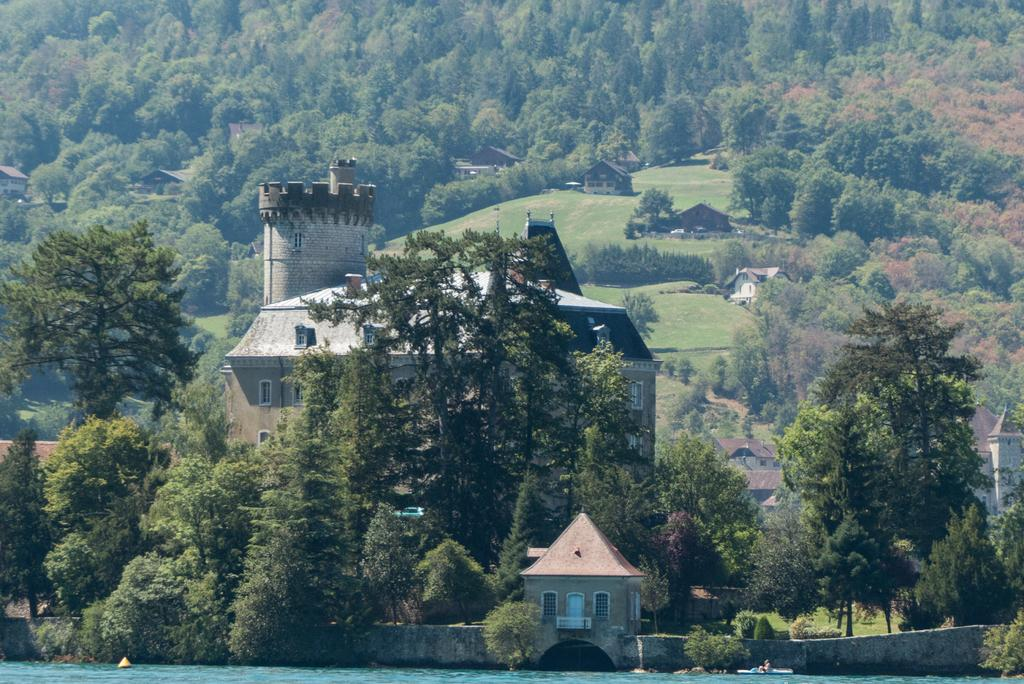What is located in front of the image? There is water in front of the image. What can be seen in the middle of the image? There are buildings and trees in the middle of the image. What type of vegetation is present in the middle of the image? There are trees in the middle of the image. What can be seen in the background of the image? There is grass and more trees in the background of the image. What type of meat is being grilled in the image? There is no meat or grilling activity present in the image. What is the heart-shaped attraction in the image? There is no attraction or heart shape present in the image. 